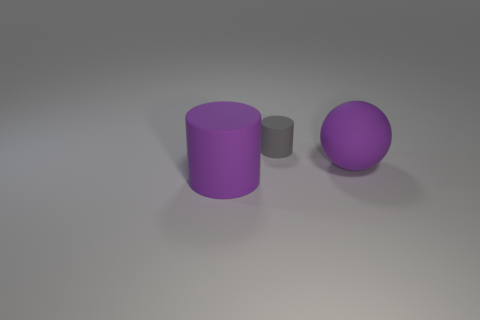Describe the arrangement of objects we see. In this image, there is a large purple cylinder on the left, a smaller gray cylinder in the center, and a large purple sphere on the right. The gray cylinder stands between the purple cylinder and the purple sphere, and the objects are placed on a plain surface with a light source creating soft shadows to their right, suggesting a light coming from the top left side.  What could this arrangement represent in a metaphorical sense? Metaphorically, the arrangement could represent a number of concepts. For instance, it might symbolize hierarchy or progression, with the large purple cylinder being the initial stage, the smaller gray cylinder an intermediate step, and the purple sphere the final, polished outcome. Alternatively, it can symbolize diversity and unity, with different shapes coexisting in harmony. 